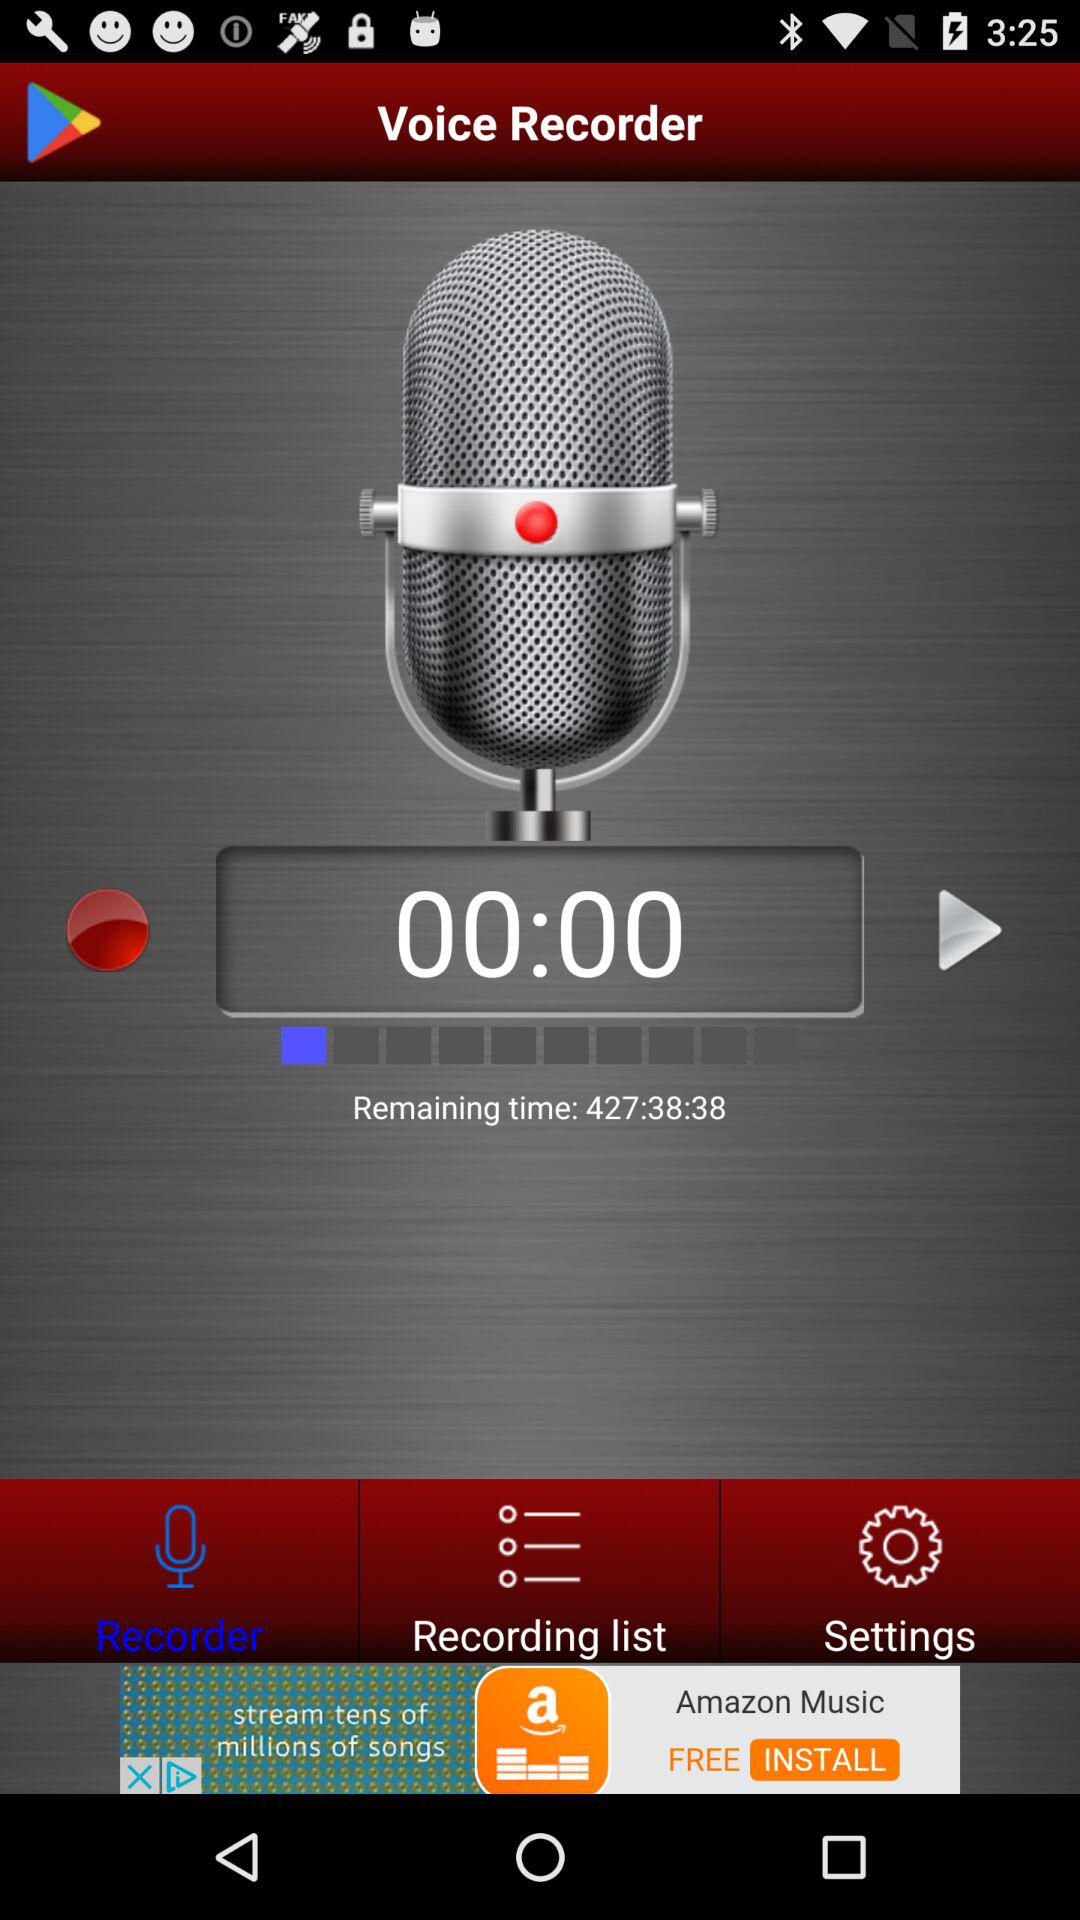What is the remaining time? The remaining time is 427 hours 38 minutes 38 seconds. 